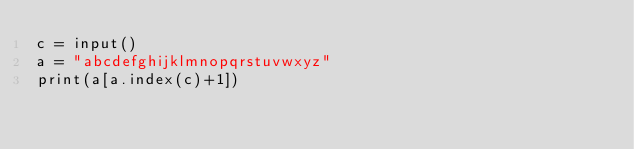Convert code to text. <code><loc_0><loc_0><loc_500><loc_500><_Python_>c = input()
a = "abcdefghijklmnopqrstuvwxyz"
print(a[a.index(c)+1])
</code> 